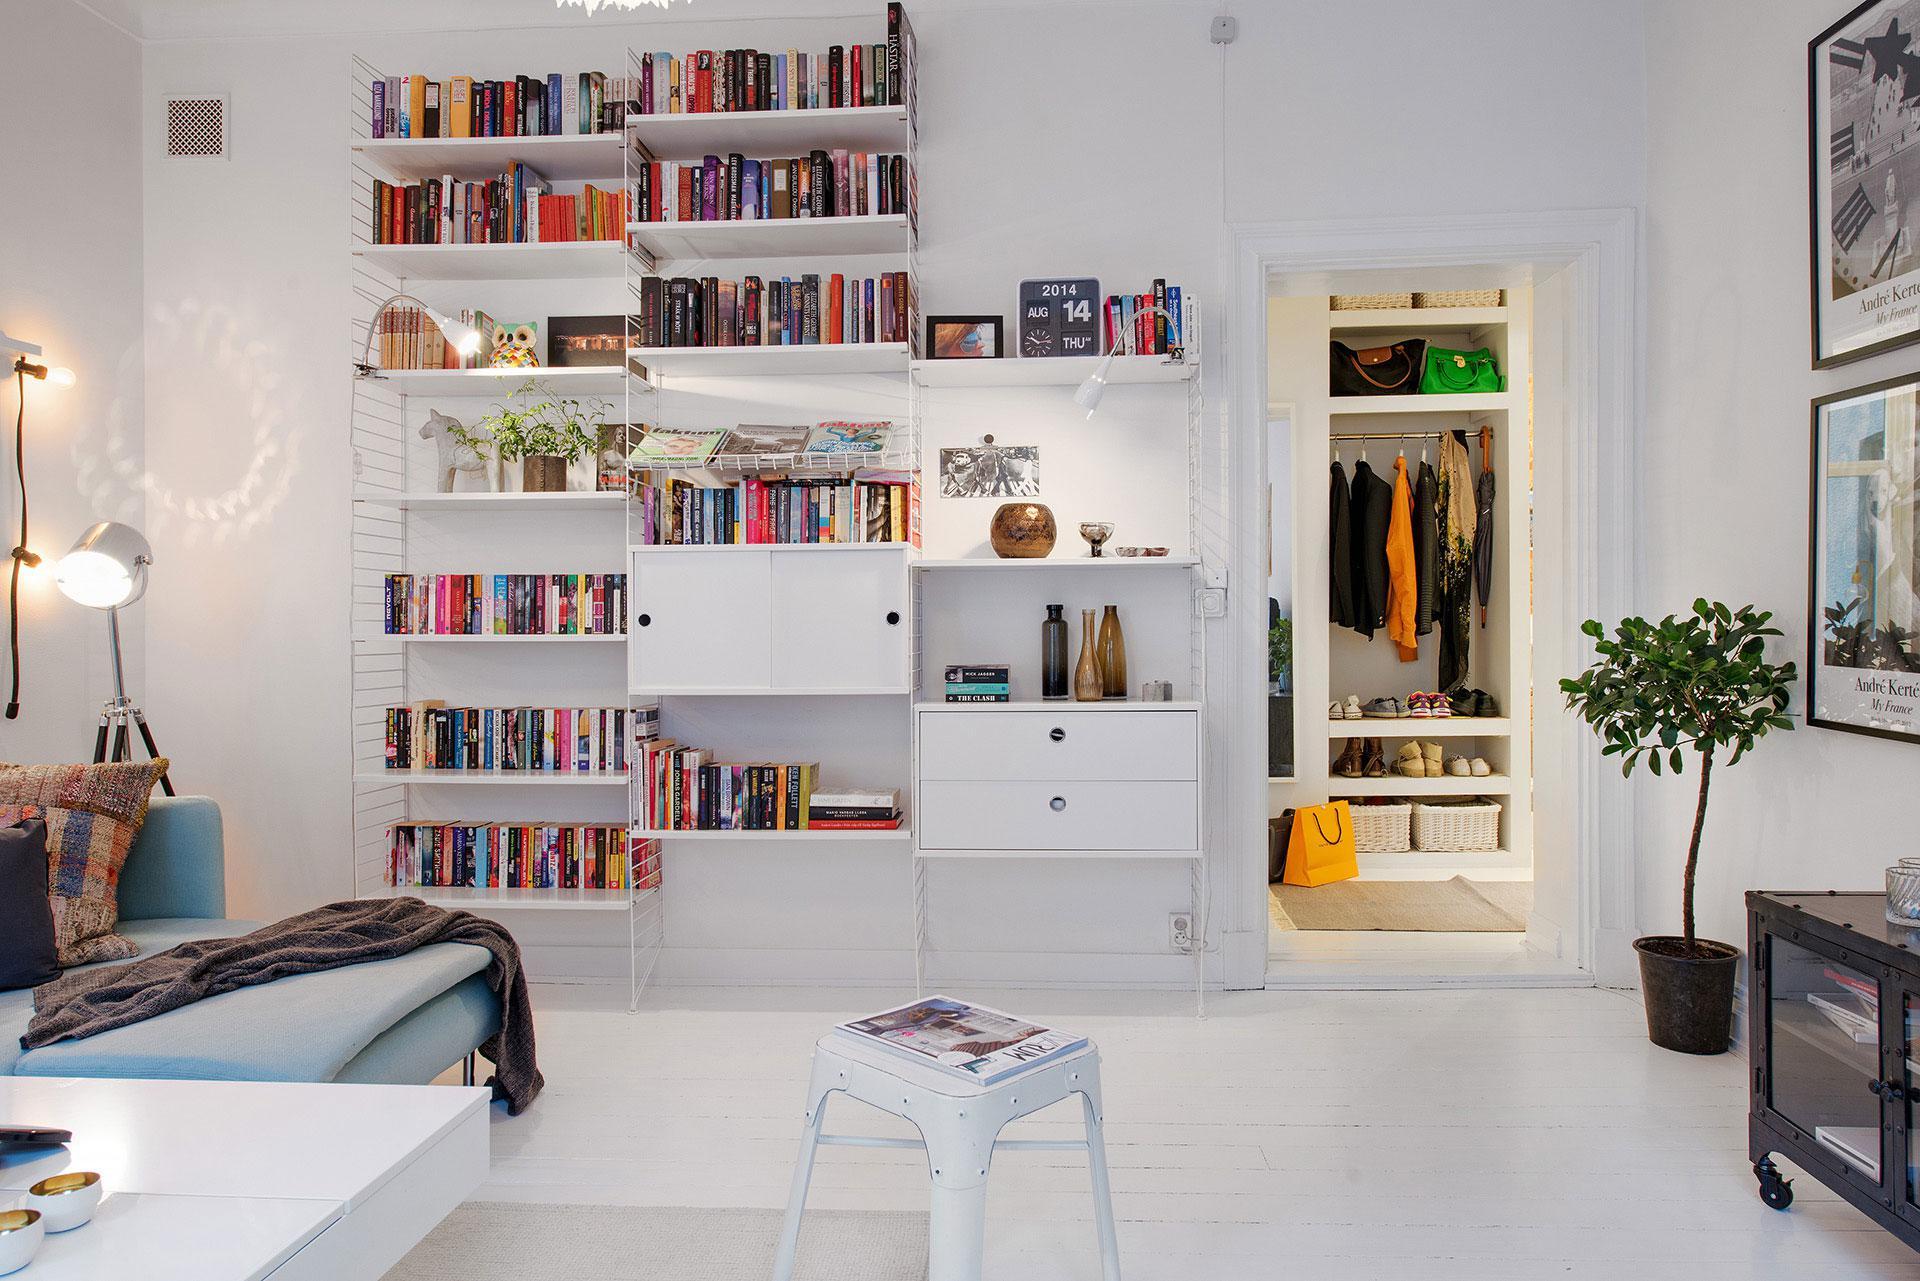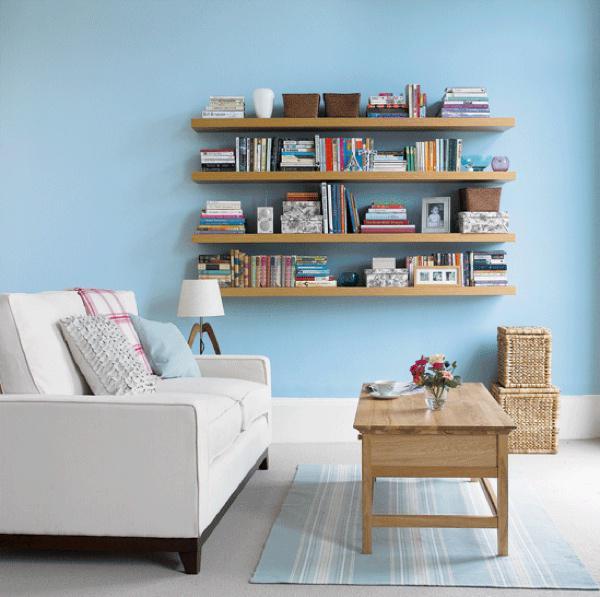The first image is the image on the left, the second image is the image on the right. For the images displayed, is the sentence "There is a potted plant sitting on the floor in the image on the left." factually correct? Answer yes or no. Yes. 